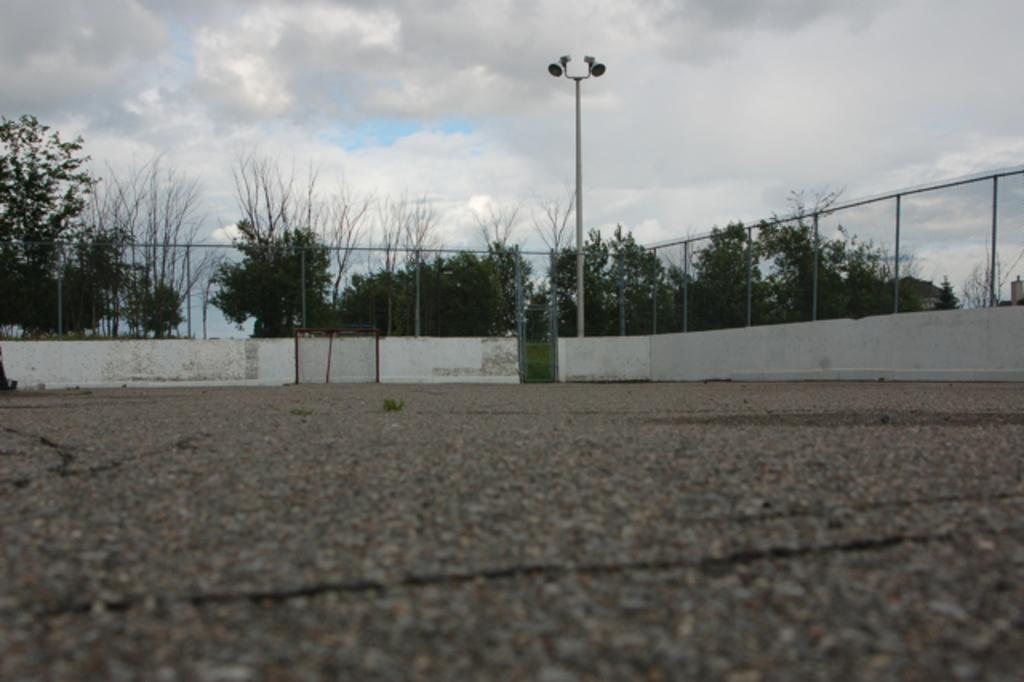What is located at the bottom of the image? There is a road at the bottom of the image. What can be seen in the center of the image? There are trees, a fence, a wall, a pole, and lights in the center of the image. What is visible at the top of the image? The sky is visible at the top of the image. What time is depicted in the image? The time is not depicted in the image; it is a still image without any indication of time. What nation is represented by the flag in the image? There is no flag present in the image, so it is not possible to determine which nation is represented. 